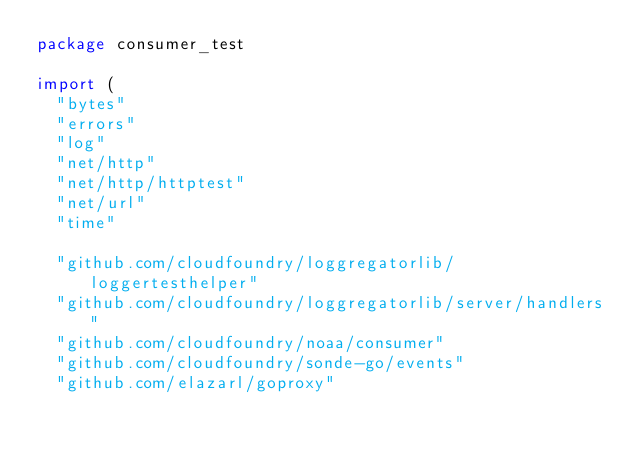Convert code to text. <code><loc_0><loc_0><loc_500><loc_500><_Go_>package consumer_test

import (
	"bytes"
	"errors"
	"log"
	"net/http"
	"net/http/httptest"
	"net/url"
	"time"

	"github.com/cloudfoundry/loggregatorlib/loggertesthelper"
	"github.com/cloudfoundry/loggregatorlib/server/handlers"
	"github.com/cloudfoundry/noaa/consumer"
	"github.com/cloudfoundry/sonde-go/events"
	"github.com/elazarl/goproxy"</code> 